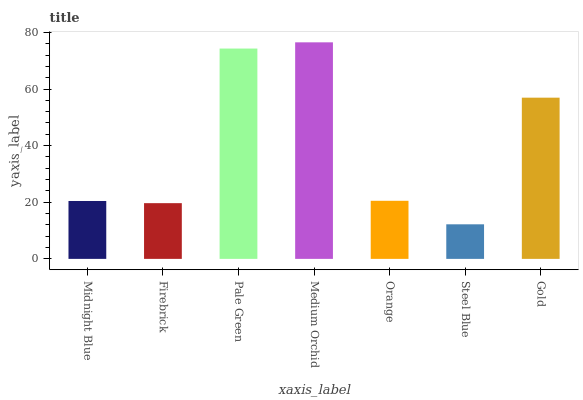Is Steel Blue the minimum?
Answer yes or no. Yes. Is Medium Orchid the maximum?
Answer yes or no. Yes. Is Firebrick the minimum?
Answer yes or no. No. Is Firebrick the maximum?
Answer yes or no. No. Is Midnight Blue greater than Firebrick?
Answer yes or no. Yes. Is Firebrick less than Midnight Blue?
Answer yes or no. Yes. Is Firebrick greater than Midnight Blue?
Answer yes or no. No. Is Midnight Blue less than Firebrick?
Answer yes or no. No. Is Orange the high median?
Answer yes or no. Yes. Is Orange the low median?
Answer yes or no. Yes. Is Midnight Blue the high median?
Answer yes or no. No. Is Medium Orchid the low median?
Answer yes or no. No. 